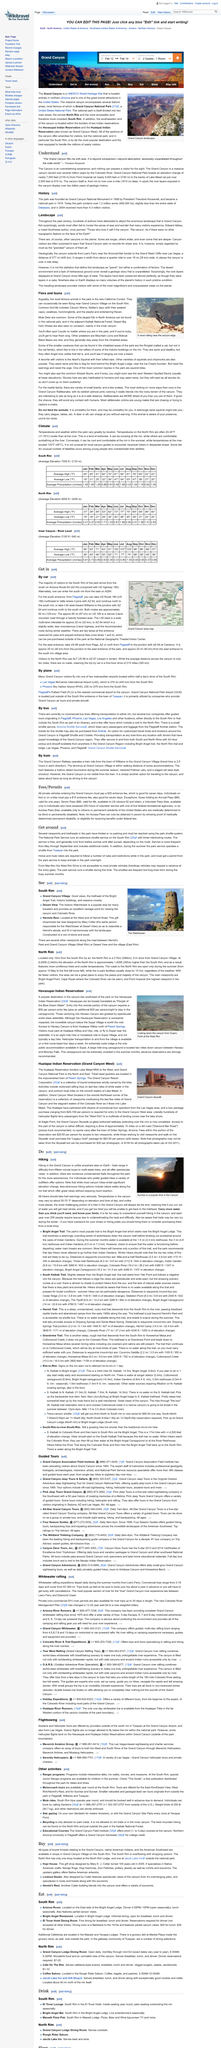Indicate a few pertinent items in this graphic. Yes, Black Bears are present in the park, although they are relatively rare and tend to stay away from inhabited areas. It is possible to find alternative viewpoints along the roads connecting Hermitt's Rest to Grand Canyon Village (West Rim) or Desert View to the village (East Rim) that offer differing perspectives of the Grand Canyon. The Grand Canyon is a sight that cannot be adequately prepared for by any prior experience. The national monument park being discussed in the article is named Grand Canyon. The most popular time to visit the Grand Canyon is sunrise, when the morning light illuminates the vast expanse of the canyon and creates a stunning visual spectacle. 